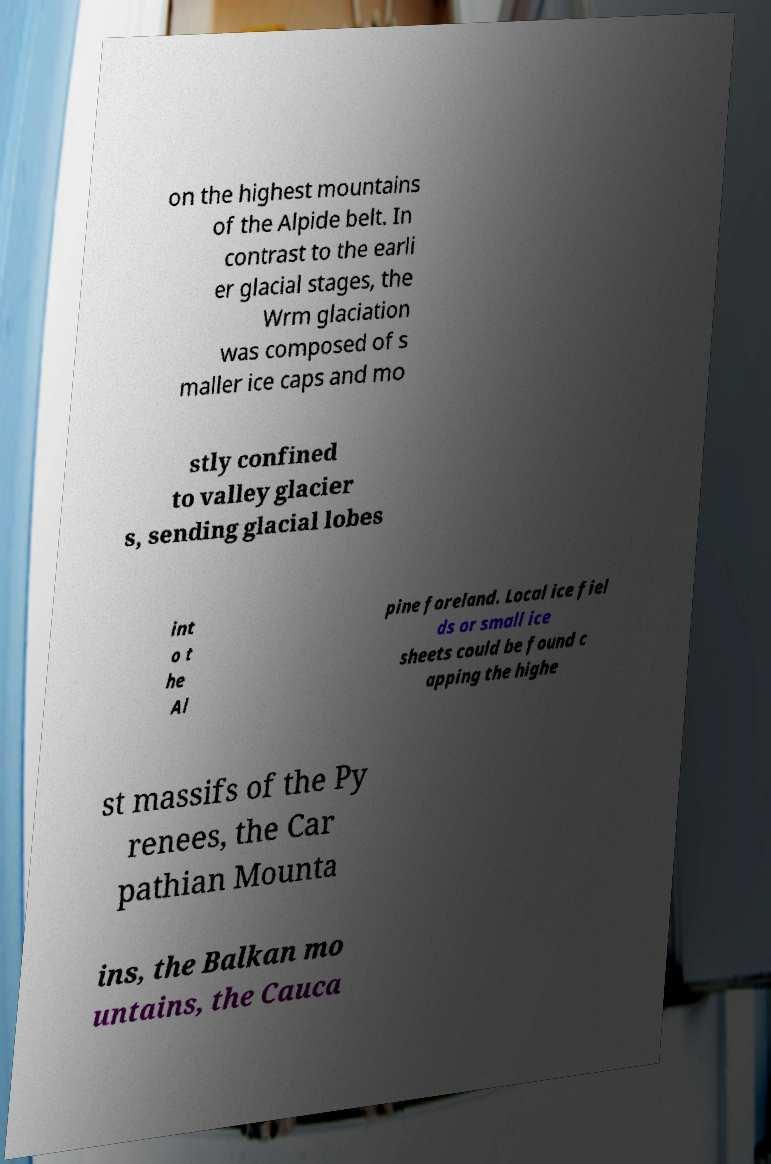Can you read and provide the text displayed in the image?This photo seems to have some interesting text. Can you extract and type it out for me? on the highest mountains of the Alpide belt. In contrast to the earli er glacial stages, the Wrm glaciation was composed of s maller ice caps and mo stly confined to valley glacier s, sending glacial lobes int o t he Al pine foreland. Local ice fiel ds or small ice sheets could be found c apping the highe st massifs of the Py renees, the Car pathian Mounta ins, the Balkan mo untains, the Cauca 